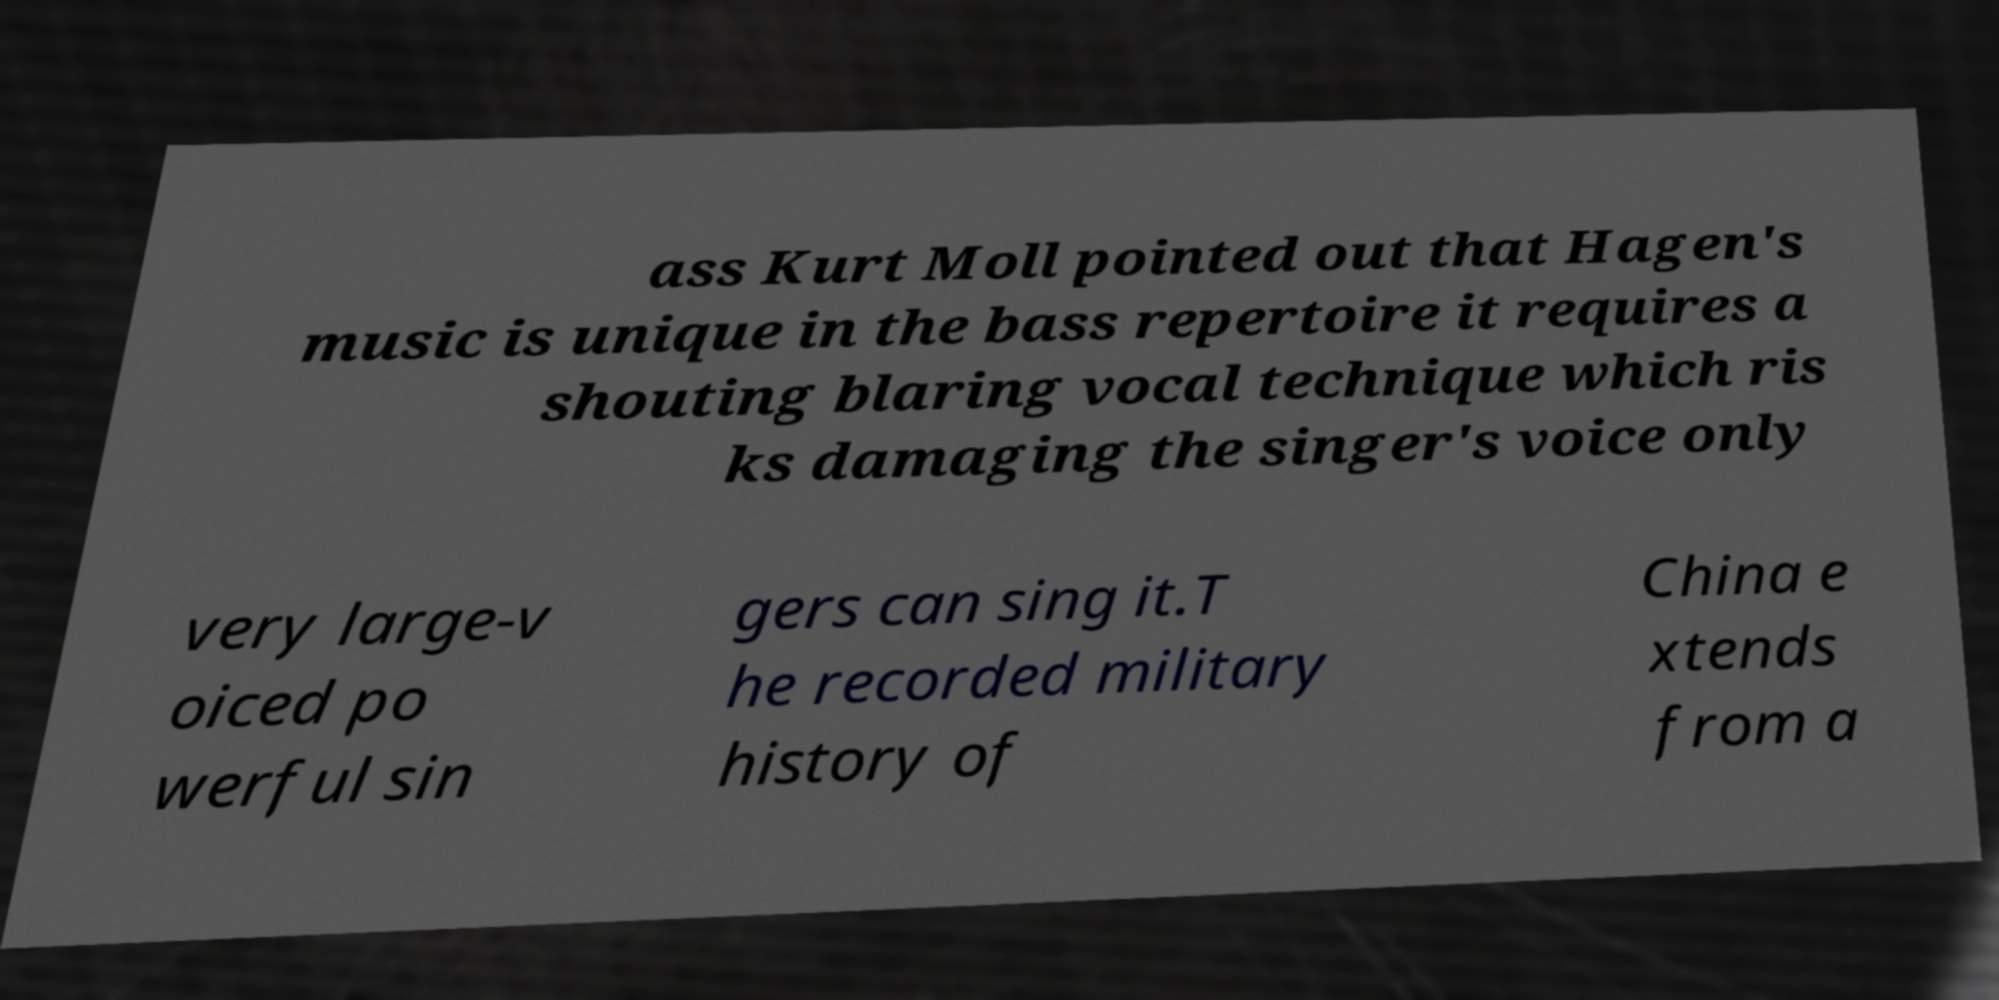Could you extract and type out the text from this image? ass Kurt Moll pointed out that Hagen's music is unique in the bass repertoire it requires a shouting blaring vocal technique which ris ks damaging the singer's voice only very large-v oiced po werful sin gers can sing it.T he recorded military history of China e xtends from a 